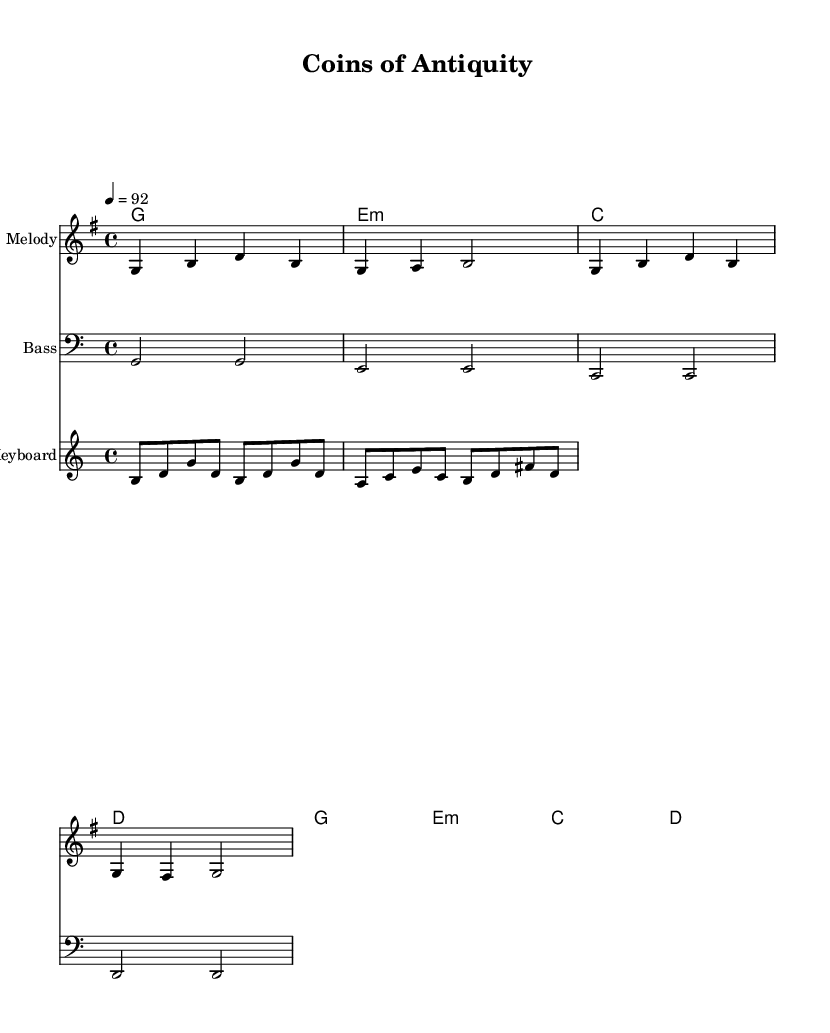What is the key signature of this music? The key signature is indicated at the beginning of the score and shows one sharp note, which corresponds to G major.
Answer: G major What is the time signature of this music? The time signature is located just after the key signature. It shows "4/4," which implies that there are four beats in each measure and the quarter note receives one beat.
Answer: 4/4 What is the tempo marking for this music? The tempo marking is found in the header section of the score and specifies a tempo of 92 beats per minute.
Answer: 92 How many lines make up the treble staff? The treble staff consists of five lines, as is standard in Western music notation.
Answer: Five What type of chords are used in the chord progression? The chord progression includes major and minor chords, specifically G major, E minor, C major, and D major.
Answer: Major and minor What instruments are represented in the sheet music? The sheet music includes parts for Melody, Bass, and Keyboard, which are indicated in the score.
Answer: Melody, Bass, Keyboard Why might ancient coins be a theme in this reggae song? The lyrics suggest the cultural significance of ancient coins, connecting them to past empires and telling historical tales, which fits the storytelling nature of reggae music.
Answer: Cultural storytelling 